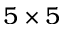<formula> <loc_0><loc_0><loc_500><loc_500>5 \times 5</formula> 